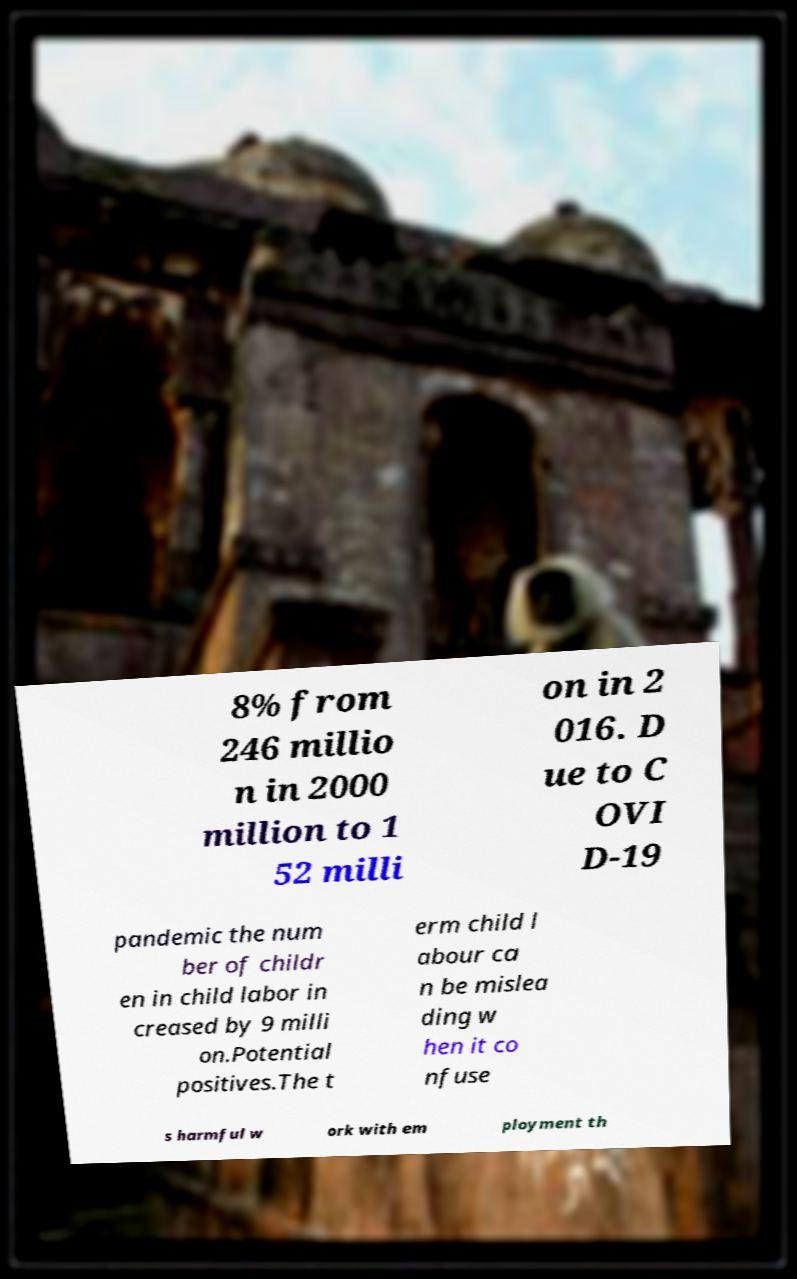For documentation purposes, I need the text within this image transcribed. Could you provide that? 8% from 246 millio n in 2000 million to 1 52 milli on in 2 016. D ue to C OVI D-19 pandemic the num ber of childr en in child labor in creased by 9 milli on.Potential positives.The t erm child l abour ca n be mislea ding w hen it co nfuse s harmful w ork with em ployment th 